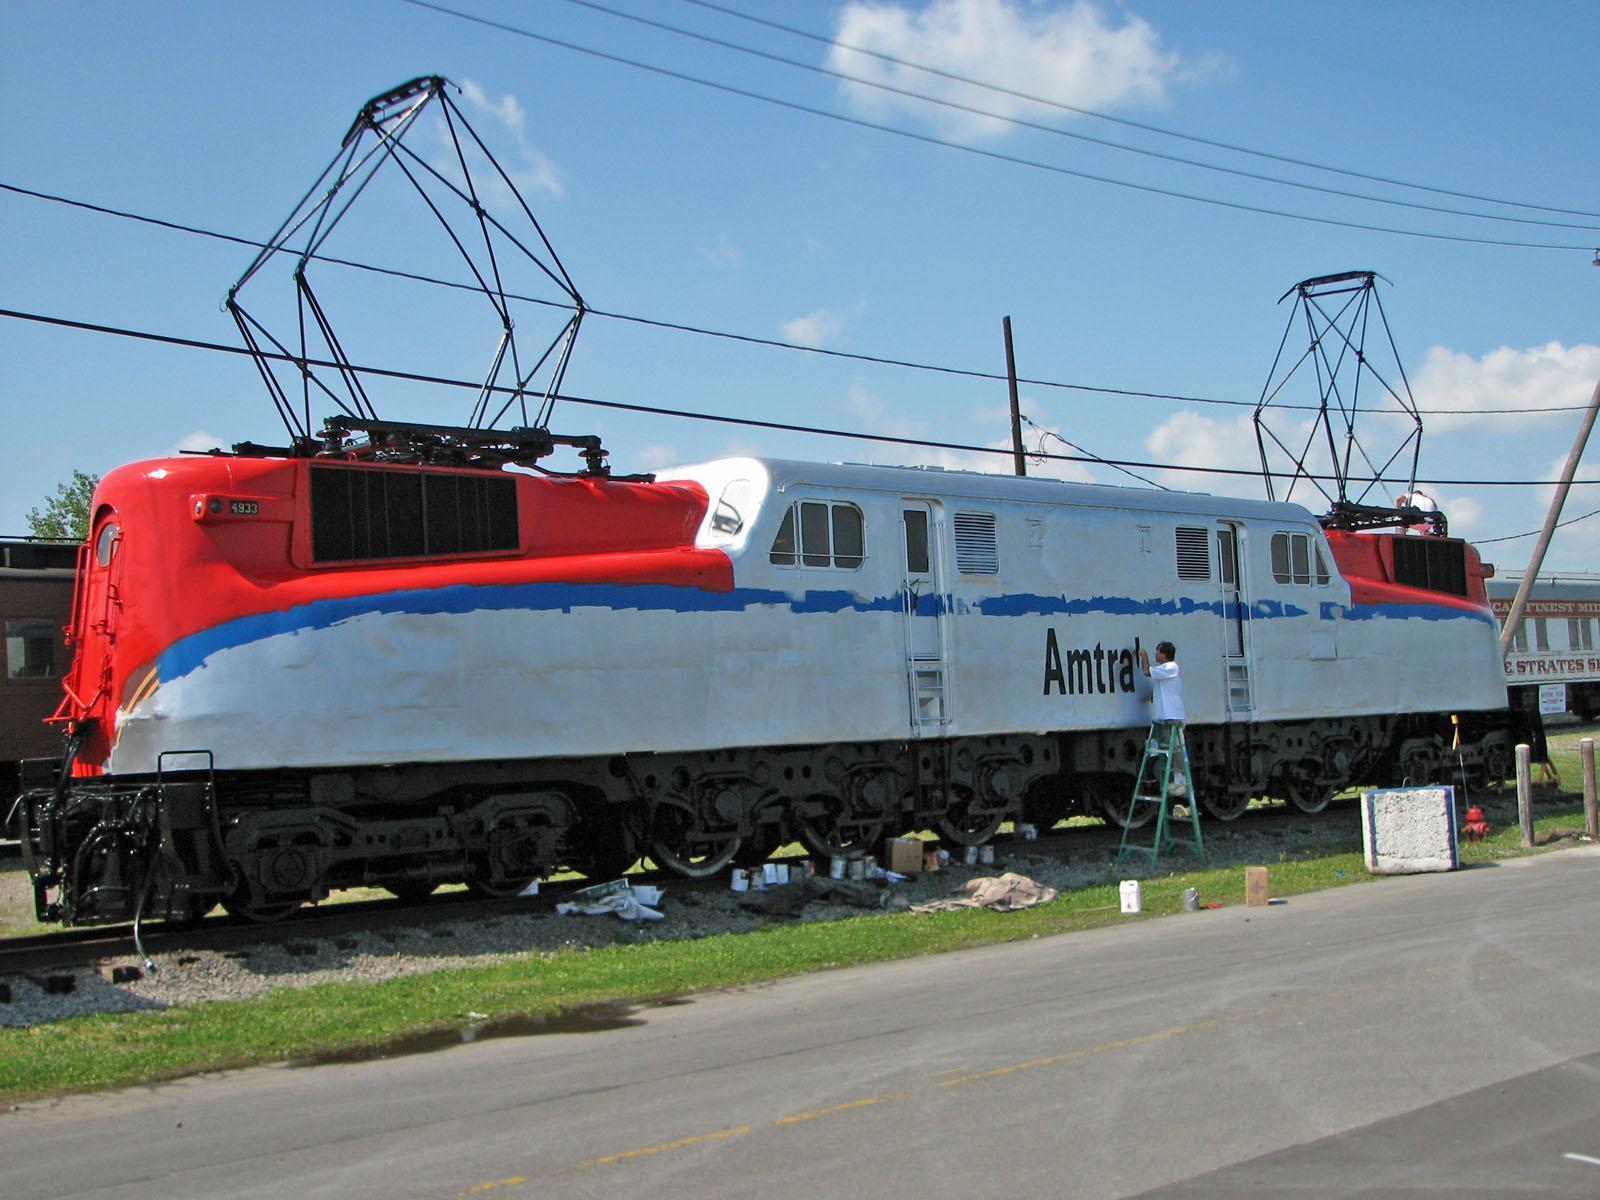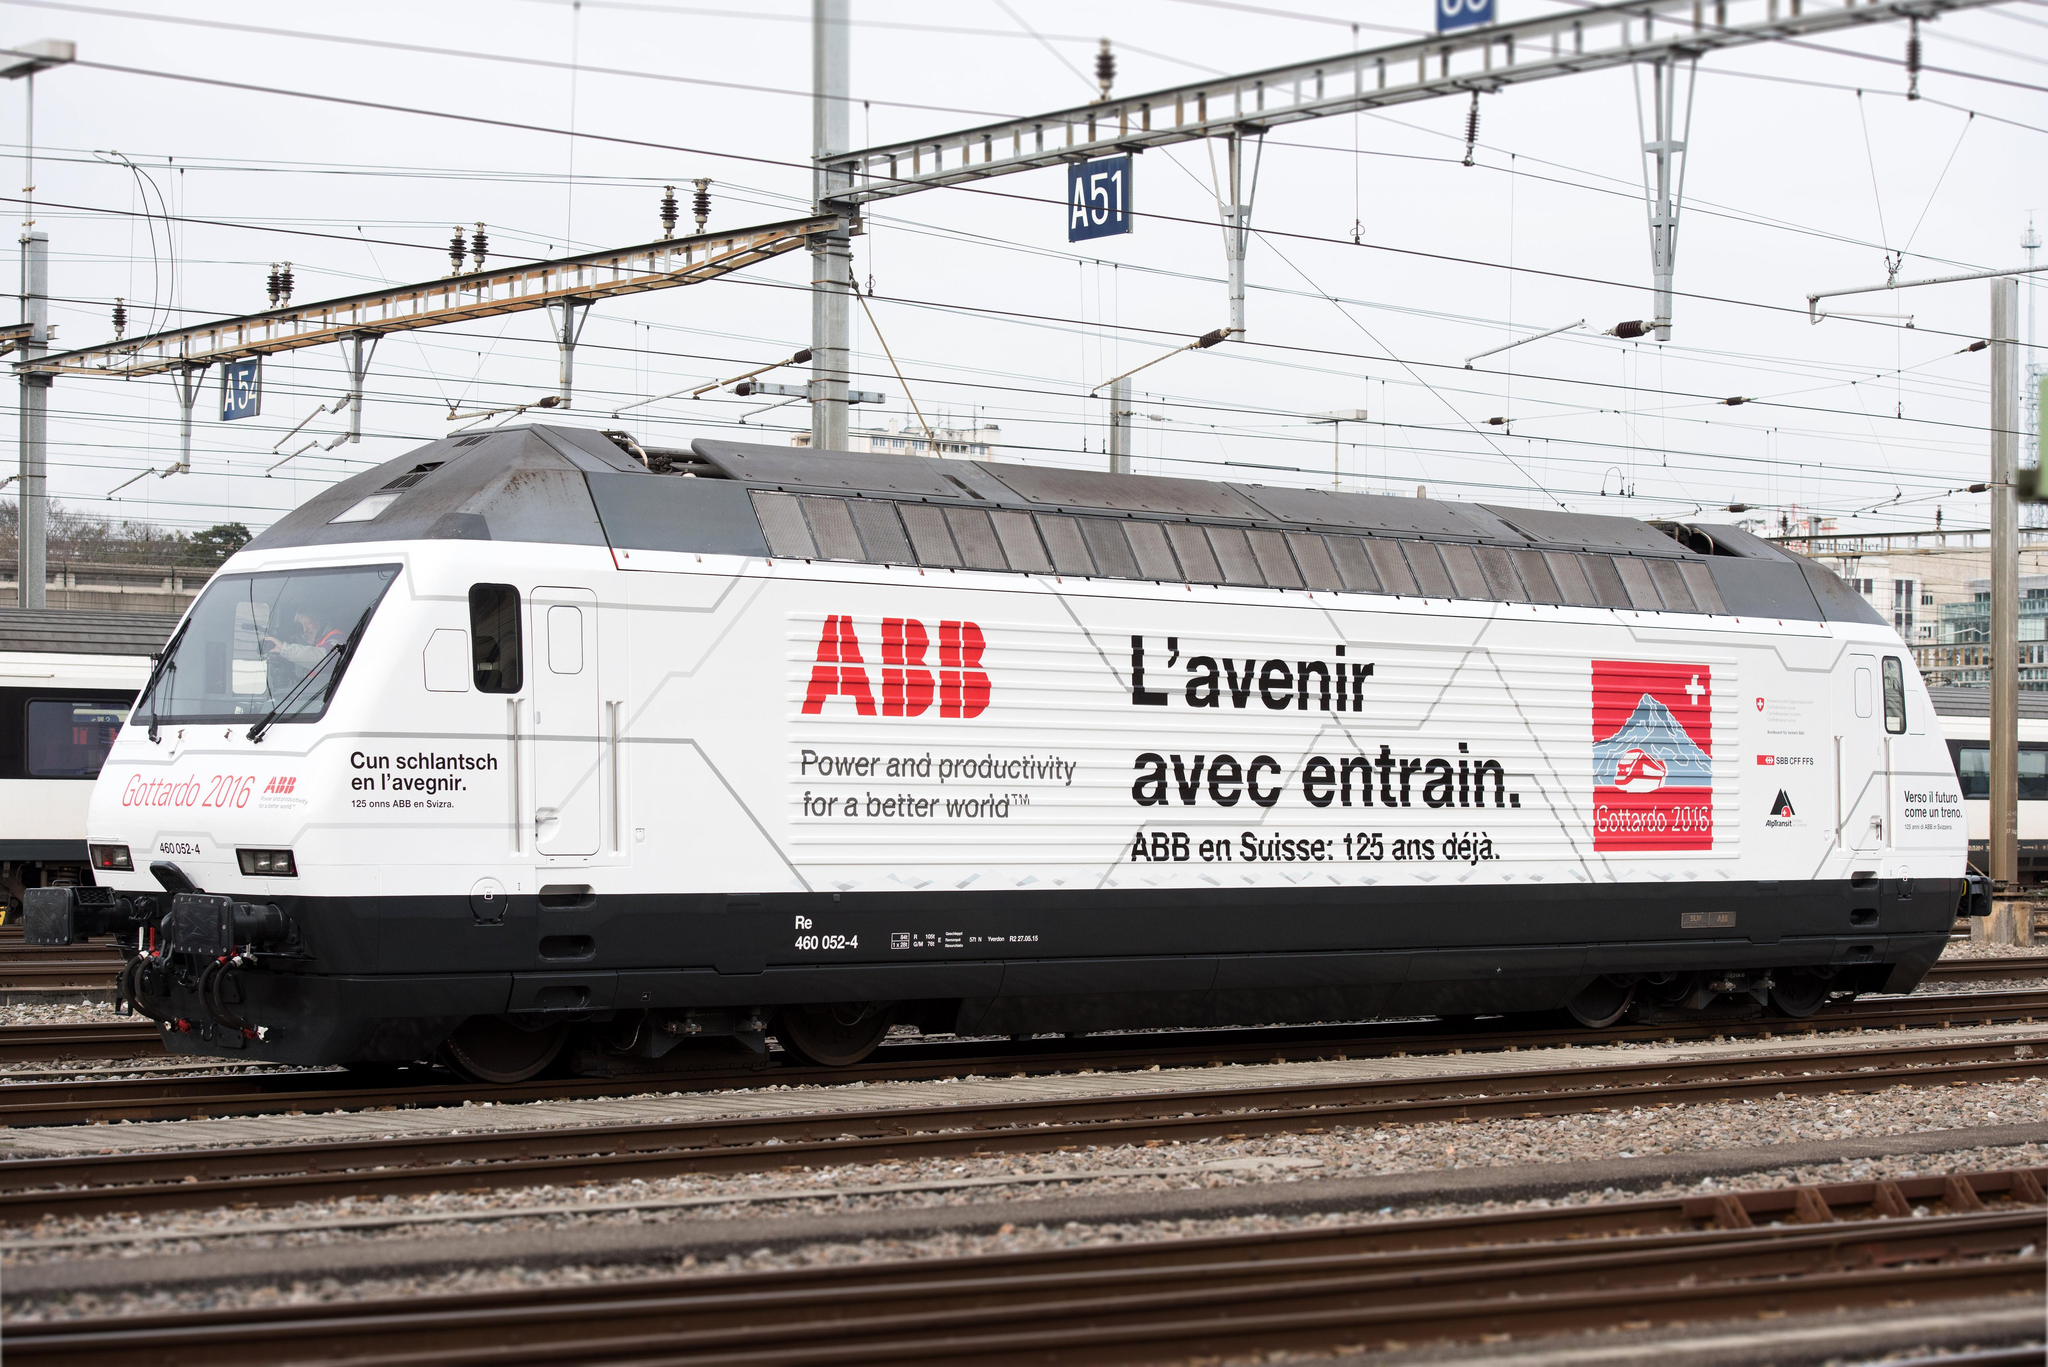The first image is the image on the left, the second image is the image on the right. Assess this claim about the two images: "Both trains are facing left.". Correct or not? Answer yes or no. Yes. The first image is the image on the left, the second image is the image on the right. Considering the images on both sides, is "One of the trains features the colors red, white, and blue with a blue stripe running the entire length of the car." valid? Answer yes or no. Yes. 